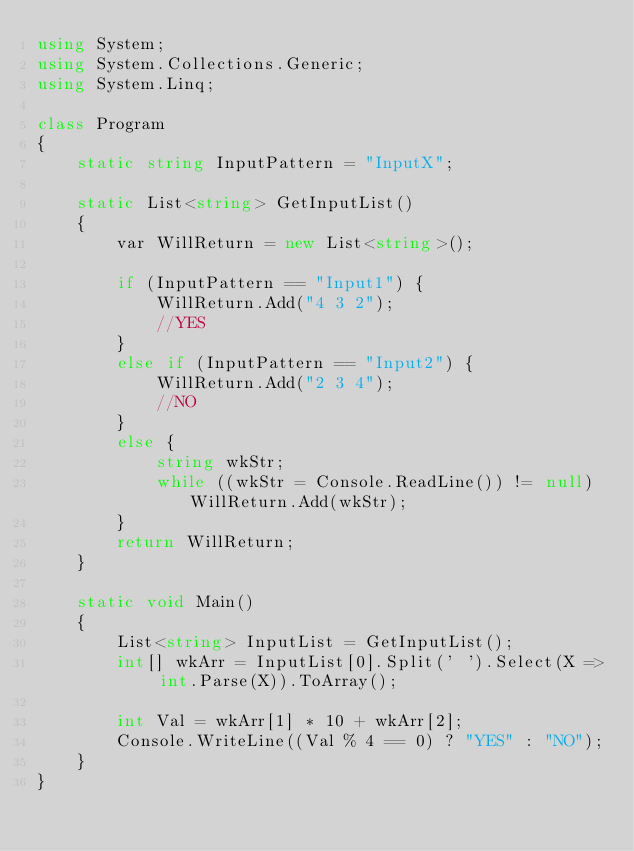Convert code to text. <code><loc_0><loc_0><loc_500><loc_500><_C#_>using System;
using System.Collections.Generic;
using System.Linq;

class Program
{
    static string InputPattern = "InputX";

    static List<string> GetInputList()
    {
        var WillReturn = new List<string>();

        if (InputPattern == "Input1") {
            WillReturn.Add("4 3 2");
            //YES
        }
        else if (InputPattern == "Input2") {
            WillReturn.Add("2 3 4");
            //NO
        }
        else {
            string wkStr;
            while ((wkStr = Console.ReadLine()) != null) WillReturn.Add(wkStr);
        }
        return WillReturn;
    }

    static void Main()
    {
        List<string> InputList = GetInputList();
        int[] wkArr = InputList[0].Split(' ').Select(X => int.Parse(X)).ToArray();

        int Val = wkArr[1] * 10 + wkArr[2];
        Console.WriteLine((Val % 4 == 0) ? "YES" : "NO");
    }
}
</code> 